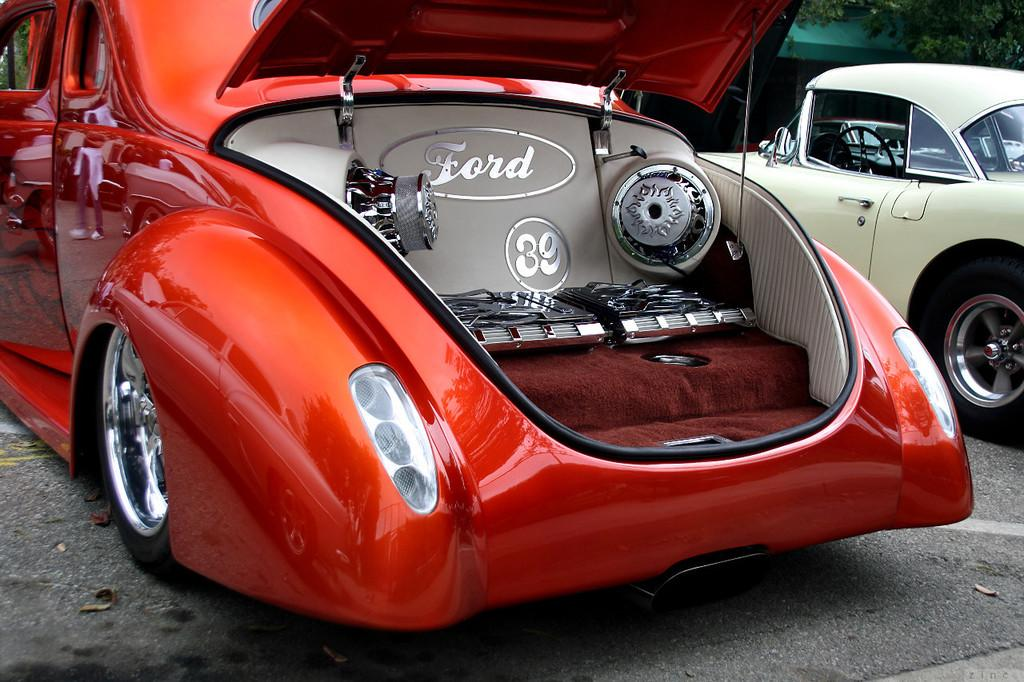Provide a one-sentence caption for the provided image. Car with the trunk open showing the word ford and speakers. 